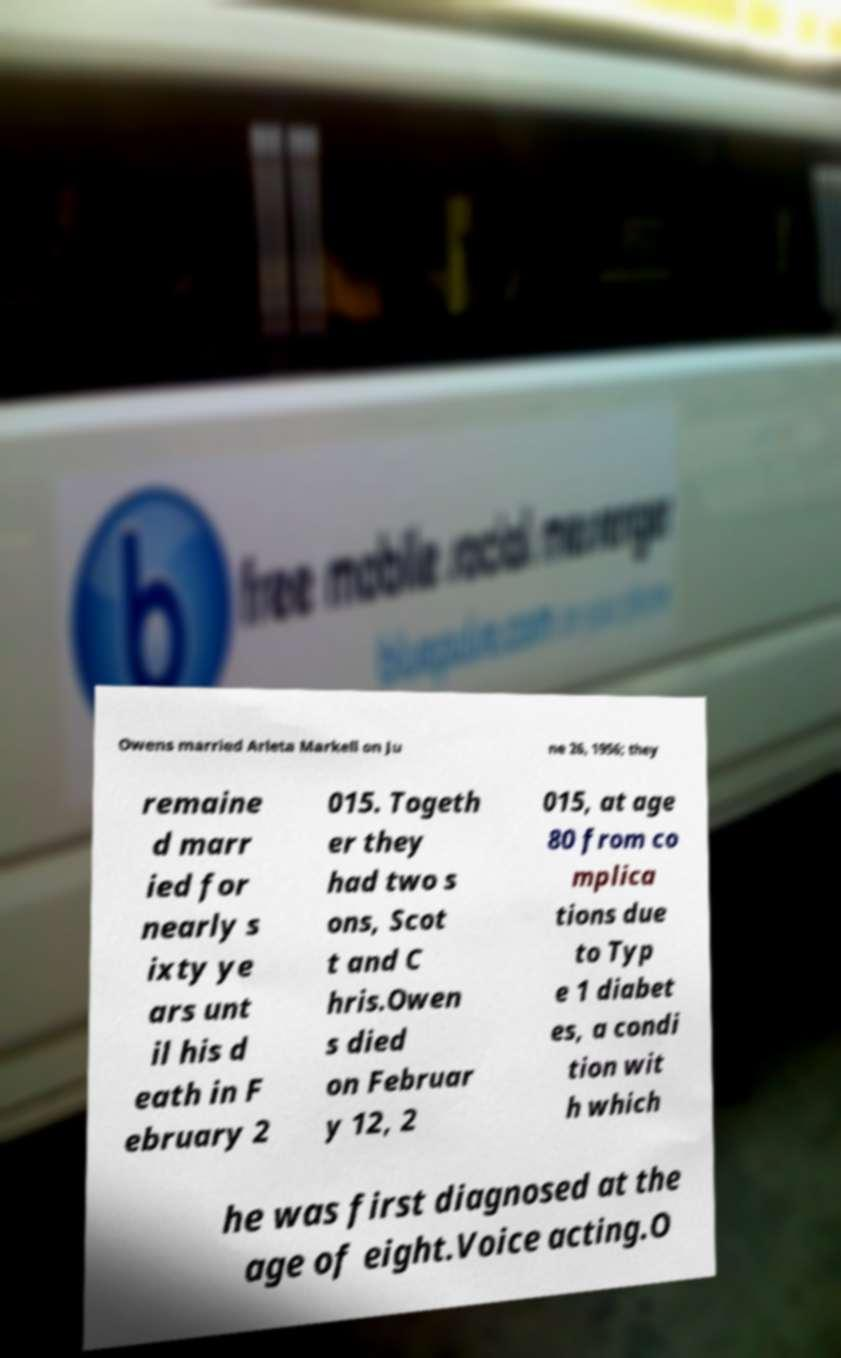I need the written content from this picture converted into text. Can you do that? Owens married Arleta Markell on Ju ne 26, 1956; they remaine d marr ied for nearly s ixty ye ars unt il his d eath in F ebruary 2 015. Togeth er they had two s ons, Scot t and C hris.Owen s died on Februar y 12, 2 015, at age 80 from co mplica tions due to Typ e 1 diabet es, a condi tion wit h which he was first diagnosed at the age of eight.Voice acting.O 